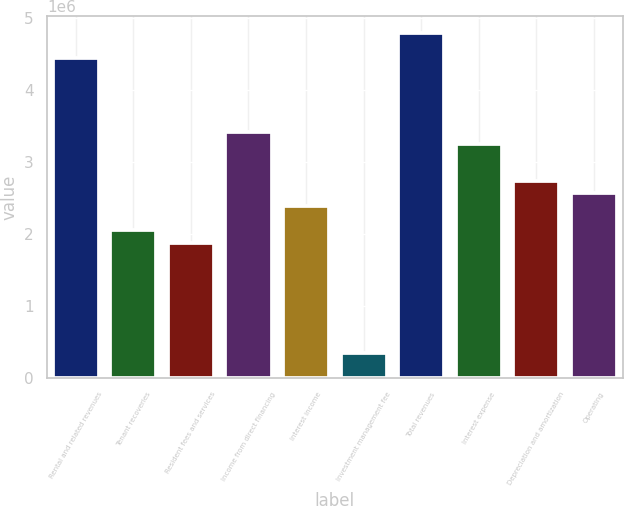Convert chart to OTSL. <chart><loc_0><loc_0><loc_500><loc_500><bar_chart><fcel>Rental and related revenues<fcel>Tenant recoveries<fcel>Resident fees and services<fcel>Income from direct financing<fcel>Interest income<fcel>Investment management fee<fcel>Total revenues<fcel>Interest expense<fcel>Depreciation and amortization<fcel>Operating<nl><fcel>4.45145e+06<fcel>2.05452e+06<fcel>1.88331e+06<fcel>3.42419e+06<fcel>2.39693e+06<fcel>342419<fcel>4.79387e+06<fcel>3.25298e+06<fcel>2.73935e+06<fcel>2.56814e+06<nl></chart> 